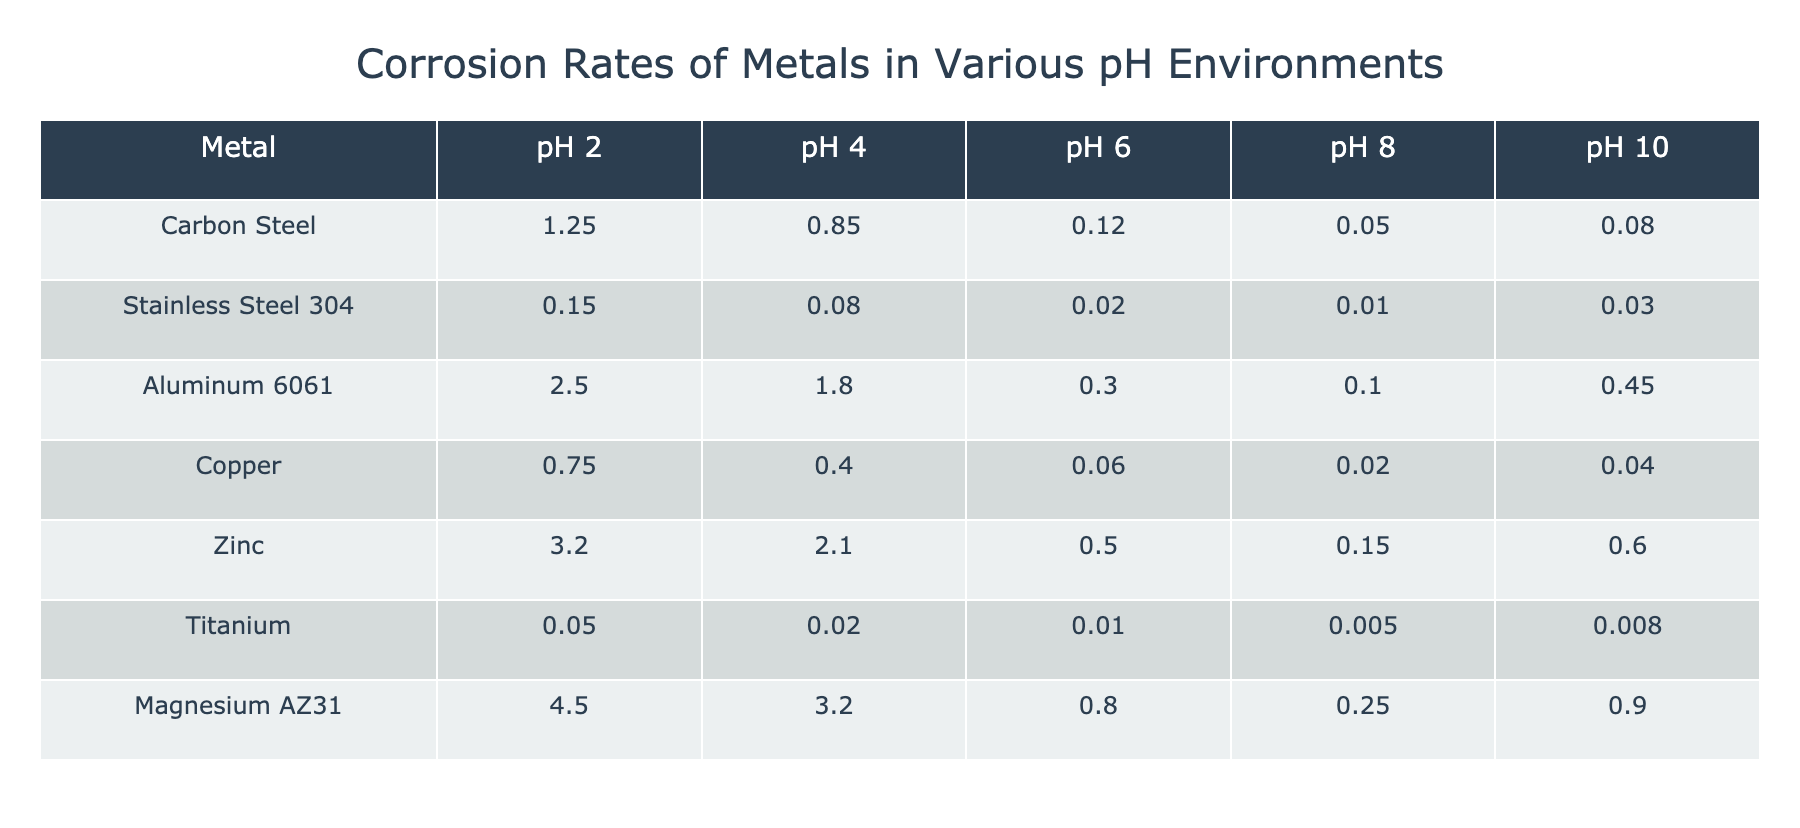What is the corrosion rate of Carbon Steel at pH 2? The table shows that the corrosion rate of Carbon Steel at pH 2 is listed as 1.25.
Answer: 1.25 Which metal has the highest corrosion rate in acidic conditions (pH 2)? Looking at the corrosion rates at pH 2, Aluminum 6061 has the highest rate at 2.50, while all other metals have lower rates.
Answer: Aluminum 6061 What is the corrosion rate of Titanium at pH 4? The table indicates that Titanium has a corrosion rate of 0.02 at pH 4.
Answer: 0.02 What is the average corrosion rate of Copper across all pH levels? The corrosion rates of Copper are 0.75, 0.40, 0.06, 0.02, and 0.04. Adding these gives 1.27, and dividing by 5 results in an average corrosion rate of 1.27/5 which equals 0.254.
Answer: 0.254 Does Magnesium AZ31 demonstrate a lower corrosion rate at pH 8 than at pH 6? At pH 6, Magnesium AZ31 has a corrosion rate of 0.80, and at pH 8, it has a corrosion rate of 0.25. Since 0.25 is lower than 0.80, the answer is yes.
Answer: Yes Which metals have a corrosion rate below 0.1 at pH 8? At pH 8, the metals with a corrosion rate below 0.1 are Stainless Steel 304 (0.01) and Titanium (0.005). So, there are two metals that meet this criterion.
Answer: Stainless Steel 304 and Titanium What is the difference in corrosion rate between Zinc at pH 2 and Aluminum 6061 at pH 2? Zinc has a corrosion rate of 3.20 at pH 2, and Aluminum 6061 has a corrosion rate of 2.50 at the same pH. The difference is 3.20 - 2.50 = 0.70.
Answer: 0.70 Is the corrosion rate of Stainless Steel 304 consistently low (under 0.1) at all pH levels? Checking the values for Stainless Steel 304, at pH 2 it is 0.15, at pH 4 it is 0.08, at pH 6 it is 0.02, at pH 8 it is 0.01, and at pH 10 it is 0.03. Since the rate at pH 2 is above 0.1, the answer is no.
Answer: No What is the total corrosion rate of Magnesium AZ31 at pH 4 and pH 10 combined? The corrosion rate of Magnesium AZ31 at pH 4 is 3.20 and at pH 10 is 0.90. Adding them gives a total of 3.20 + 0.90 = 4.10.
Answer: 4.10 